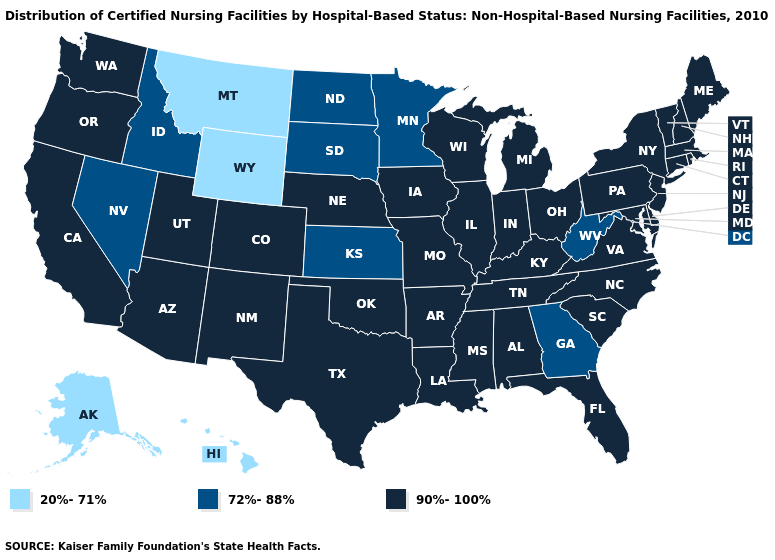Does the first symbol in the legend represent the smallest category?
Write a very short answer. Yes. What is the value of Ohio?
Concise answer only. 90%-100%. What is the value of Oklahoma?
Short answer required. 90%-100%. What is the value of New Jersey?
Give a very brief answer. 90%-100%. What is the value of Kansas?
Be succinct. 72%-88%. What is the lowest value in states that border Kansas?
Quick response, please. 90%-100%. Name the states that have a value in the range 90%-100%?
Keep it brief. Alabama, Arizona, Arkansas, California, Colorado, Connecticut, Delaware, Florida, Illinois, Indiana, Iowa, Kentucky, Louisiana, Maine, Maryland, Massachusetts, Michigan, Mississippi, Missouri, Nebraska, New Hampshire, New Jersey, New Mexico, New York, North Carolina, Ohio, Oklahoma, Oregon, Pennsylvania, Rhode Island, South Carolina, Tennessee, Texas, Utah, Vermont, Virginia, Washington, Wisconsin. Which states have the lowest value in the USA?
Give a very brief answer. Alaska, Hawaii, Montana, Wyoming. Name the states that have a value in the range 90%-100%?
Be succinct. Alabama, Arizona, Arkansas, California, Colorado, Connecticut, Delaware, Florida, Illinois, Indiana, Iowa, Kentucky, Louisiana, Maine, Maryland, Massachusetts, Michigan, Mississippi, Missouri, Nebraska, New Hampshire, New Jersey, New Mexico, New York, North Carolina, Ohio, Oklahoma, Oregon, Pennsylvania, Rhode Island, South Carolina, Tennessee, Texas, Utah, Vermont, Virginia, Washington, Wisconsin. What is the value of Alaska?
Give a very brief answer. 20%-71%. Does New York have the same value as New Jersey?
Concise answer only. Yes. What is the value of Illinois?
Give a very brief answer. 90%-100%. Among the states that border Maine , which have the lowest value?
Concise answer only. New Hampshire. What is the lowest value in the West?
Concise answer only. 20%-71%. Does Connecticut have the highest value in the USA?
Keep it brief. Yes. 